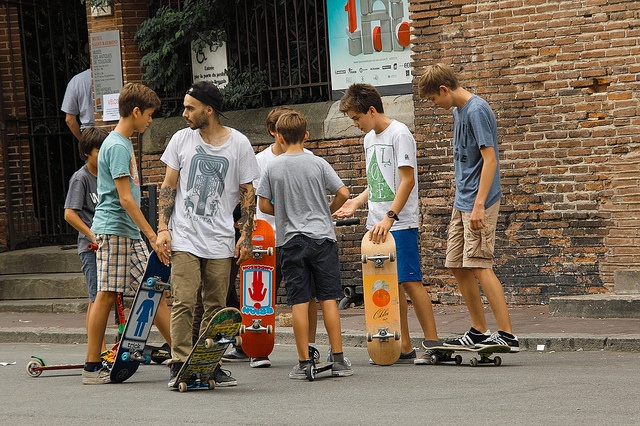Describe the objects in this image and their specific colors. I can see people in black, lightgray, darkgray, and gray tones, people in black, gray, and maroon tones, people in black, darkgray, gray, and brown tones, people in black, brown, darkgray, and gray tones, and people in black, lightgray, darkgray, brown, and navy tones in this image. 